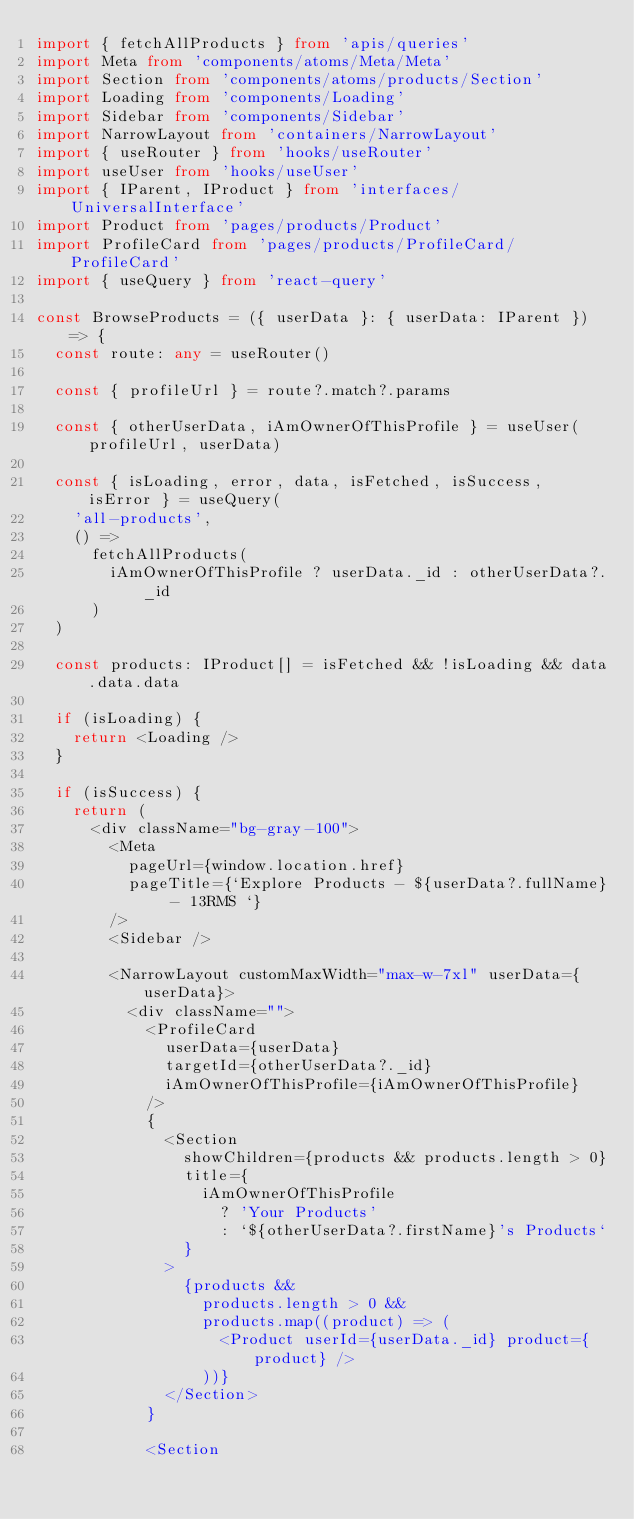Convert code to text. <code><loc_0><loc_0><loc_500><loc_500><_TypeScript_>import { fetchAllProducts } from 'apis/queries'
import Meta from 'components/atoms/Meta/Meta'
import Section from 'components/atoms/products/Section'
import Loading from 'components/Loading'
import Sidebar from 'components/Sidebar'
import NarrowLayout from 'containers/NarrowLayout'
import { useRouter } from 'hooks/useRouter'
import useUser from 'hooks/useUser'
import { IParent, IProduct } from 'interfaces/UniversalInterface'
import Product from 'pages/products/Product'
import ProfileCard from 'pages/products/ProfileCard/ProfileCard'
import { useQuery } from 'react-query'

const BrowseProducts = ({ userData }: { userData: IParent }) => {
  const route: any = useRouter()

  const { profileUrl } = route?.match?.params

  const { otherUserData, iAmOwnerOfThisProfile } = useUser(profileUrl, userData)

  const { isLoading, error, data, isFetched, isSuccess, isError } = useQuery(
    'all-products',
    () =>
      fetchAllProducts(
        iAmOwnerOfThisProfile ? userData._id : otherUserData?._id
      )
  )

  const products: IProduct[] = isFetched && !isLoading && data.data.data

  if (isLoading) {
    return <Loading />
  }

  if (isSuccess) {
    return (
      <div className="bg-gray-100">
        <Meta
          pageUrl={window.location.href}
          pageTitle={`Explore Products - ${userData?.fullName} - 13RMS `}
        />
        <Sidebar />

        <NarrowLayout customMaxWidth="max-w-7xl" userData={userData}>
          <div className="">
            <ProfileCard
              userData={userData}
              targetId={otherUserData?._id}
              iAmOwnerOfThisProfile={iAmOwnerOfThisProfile}
            />
            {
              <Section
                showChildren={products && products.length > 0}
                title={
                  iAmOwnerOfThisProfile
                    ? 'Your Products'
                    : `${otherUserData?.firstName}'s Products`
                }
              >
                {products &&
                  products.length > 0 &&
                  products.map((product) => (
                    <Product userId={userData._id} product={product} />
                  ))}
              </Section>
            }

            <Section</code> 